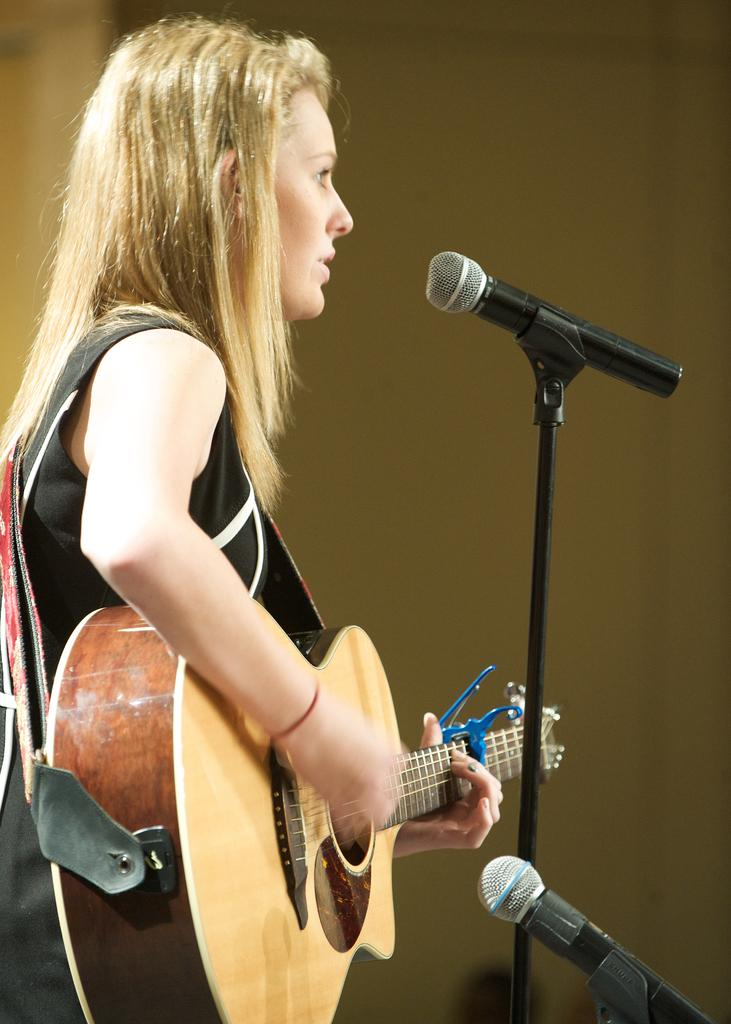What is the woman doing in the image? She is standing and playing the guitar. What is she holding while playing the guitar? She is holding a guitar. What can be seen in the background of the image? There is a white color wall in the background. What type of eggnog is she drinking while playing the guitar? There is no eggnog present in the image; she is only playing the guitar. How does she sort the toothbrushes while playing the guitar? There are no toothbrushes present in the image, and she is not sorting anything while playing the guitar. 